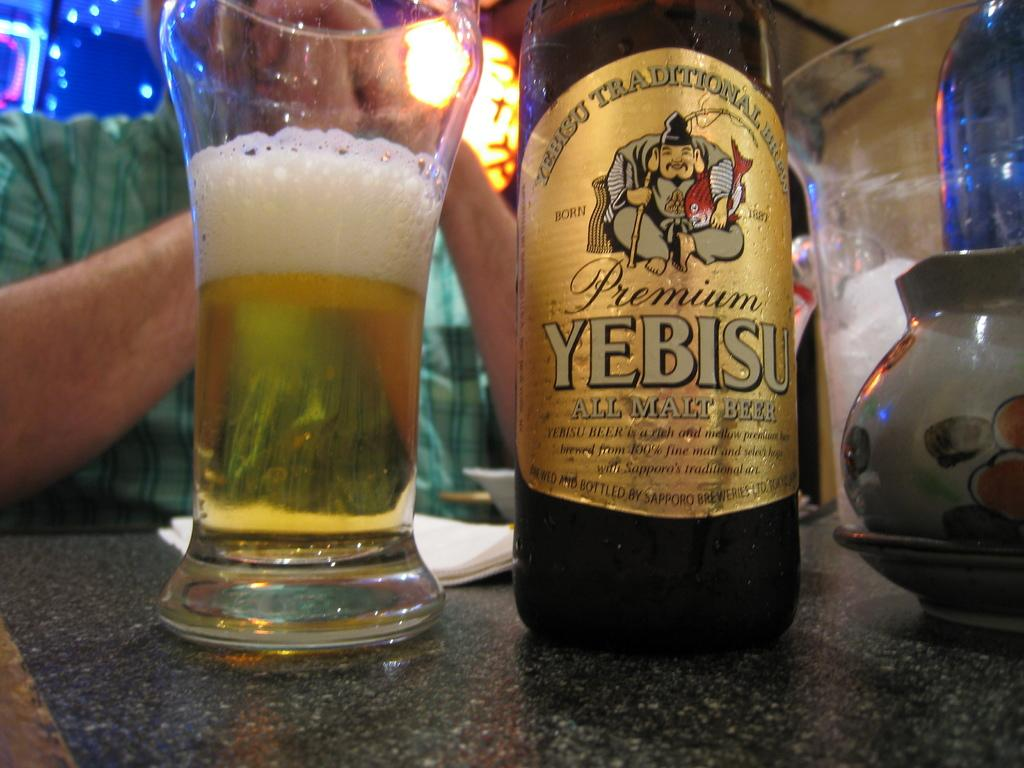<image>
Summarize the visual content of the image. a bottle of Yebisu beer next to a glass 